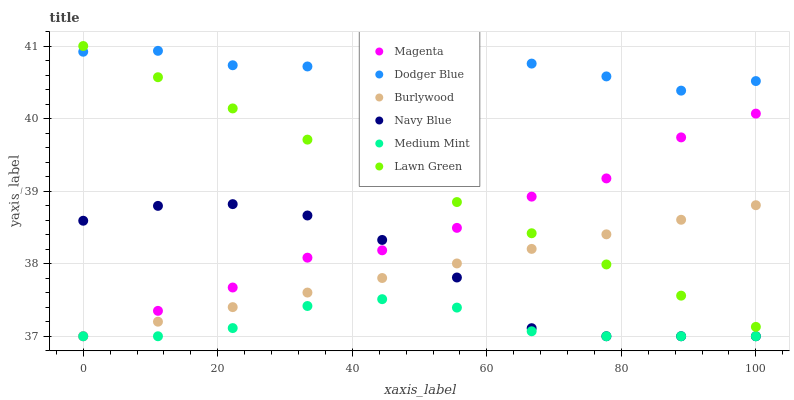Does Medium Mint have the minimum area under the curve?
Answer yes or no. Yes. Does Dodger Blue have the maximum area under the curve?
Answer yes or no. Yes. Does Lawn Green have the minimum area under the curve?
Answer yes or no. No. Does Lawn Green have the maximum area under the curve?
Answer yes or no. No. Is Lawn Green the smoothest?
Answer yes or no. Yes. Is Navy Blue the roughest?
Answer yes or no. Yes. Is Burlywood the smoothest?
Answer yes or no. No. Is Burlywood the roughest?
Answer yes or no. No. Does Medium Mint have the lowest value?
Answer yes or no. Yes. Does Lawn Green have the lowest value?
Answer yes or no. No. Does Lawn Green have the highest value?
Answer yes or no. Yes. Does Burlywood have the highest value?
Answer yes or no. No. Is Medium Mint less than Dodger Blue?
Answer yes or no. Yes. Is Dodger Blue greater than Magenta?
Answer yes or no. Yes. Does Medium Mint intersect Magenta?
Answer yes or no. Yes. Is Medium Mint less than Magenta?
Answer yes or no. No. Is Medium Mint greater than Magenta?
Answer yes or no. No. Does Medium Mint intersect Dodger Blue?
Answer yes or no. No. 